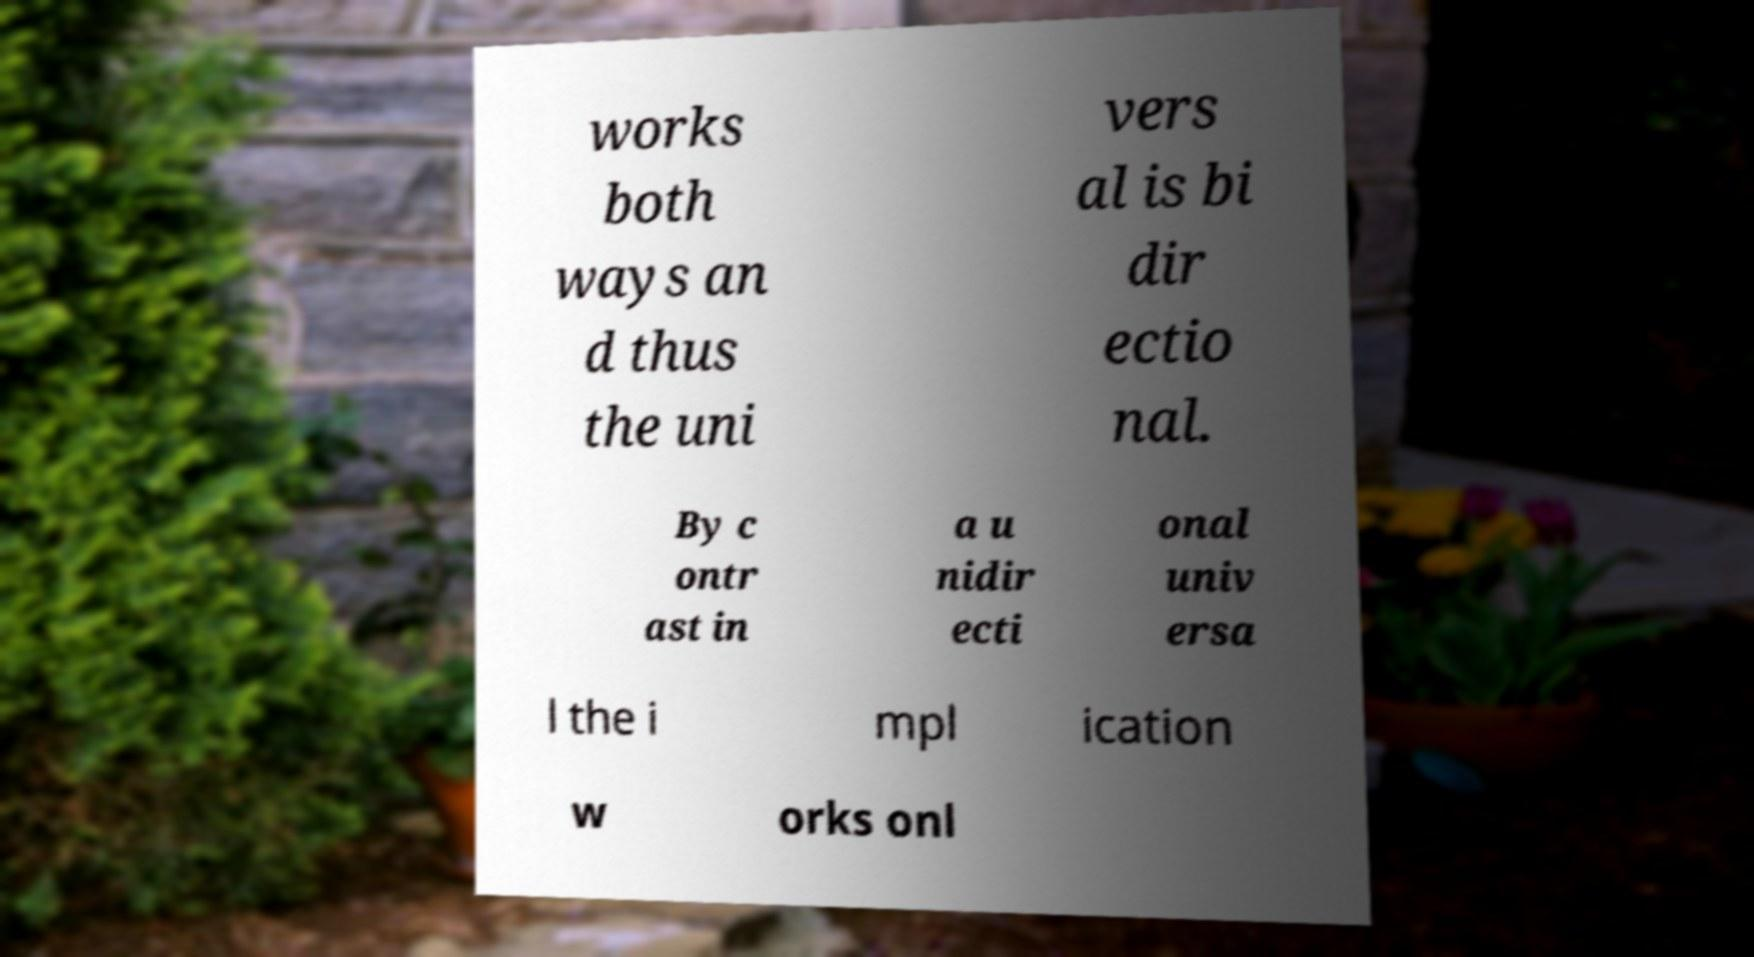What messages or text are displayed in this image? I need them in a readable, typed format. works both ways an d thus the uni vers al is bi dir ectio nal. By c ontr ast in a u nidir ecti onal univ ersa l the i mpl ication w orks onl 